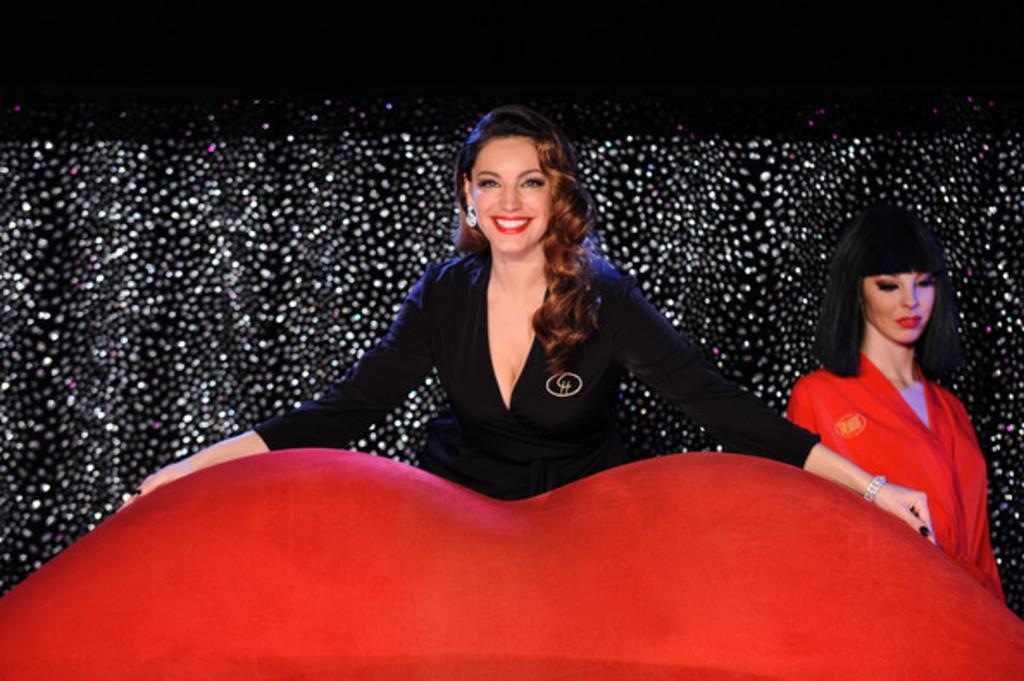How many people are in the image? There are two ladies in the image. What expressions do the ladies have? Both ladies are smiling. What is the lady on the left doing with her hand? One of the ladies has placed her hand on a red object. What can be seen in the background of the image? There are lights visible in the background of the image. What type of writing can be seen on the trousers of the lady on the right? There are no trousers visible in the image, and the lady on the right is not wearing any. Additionally, there is no writing present on any clothing in the image. 